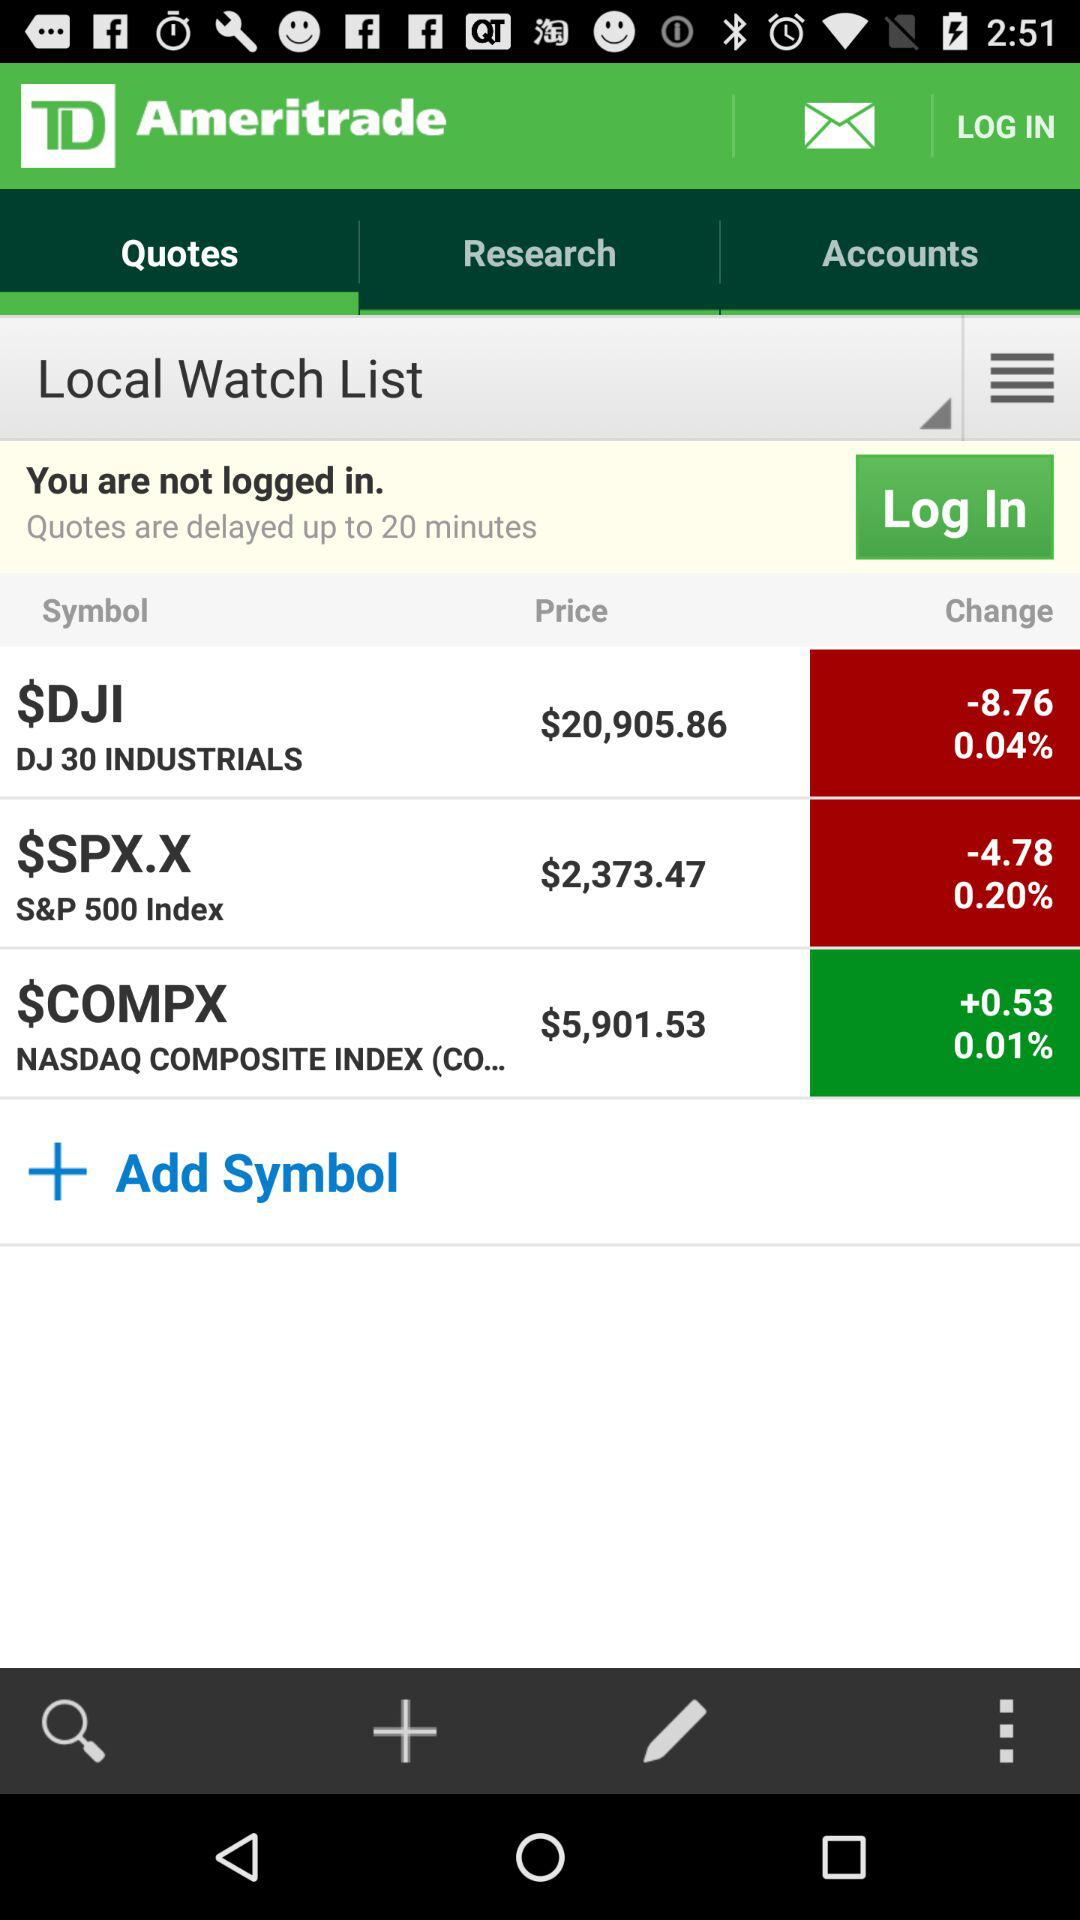What is the application name? The application name is "TD Ameritrade". 